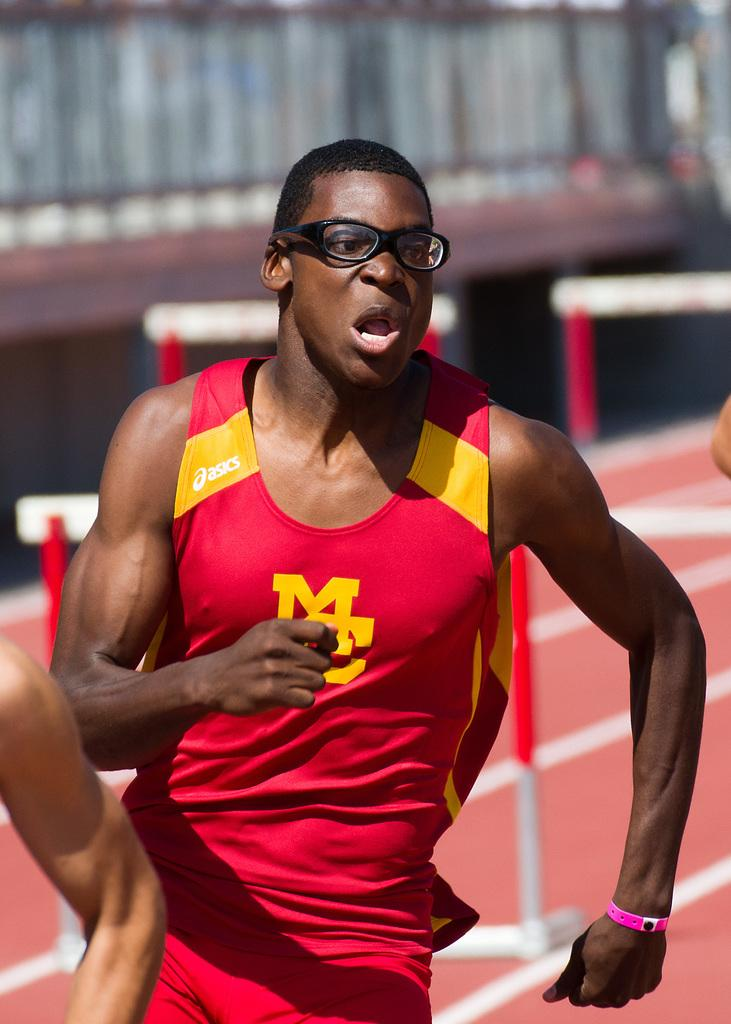<image>
Share a concise interpretation of the image provided. A man running track with the words MC on his shirt 